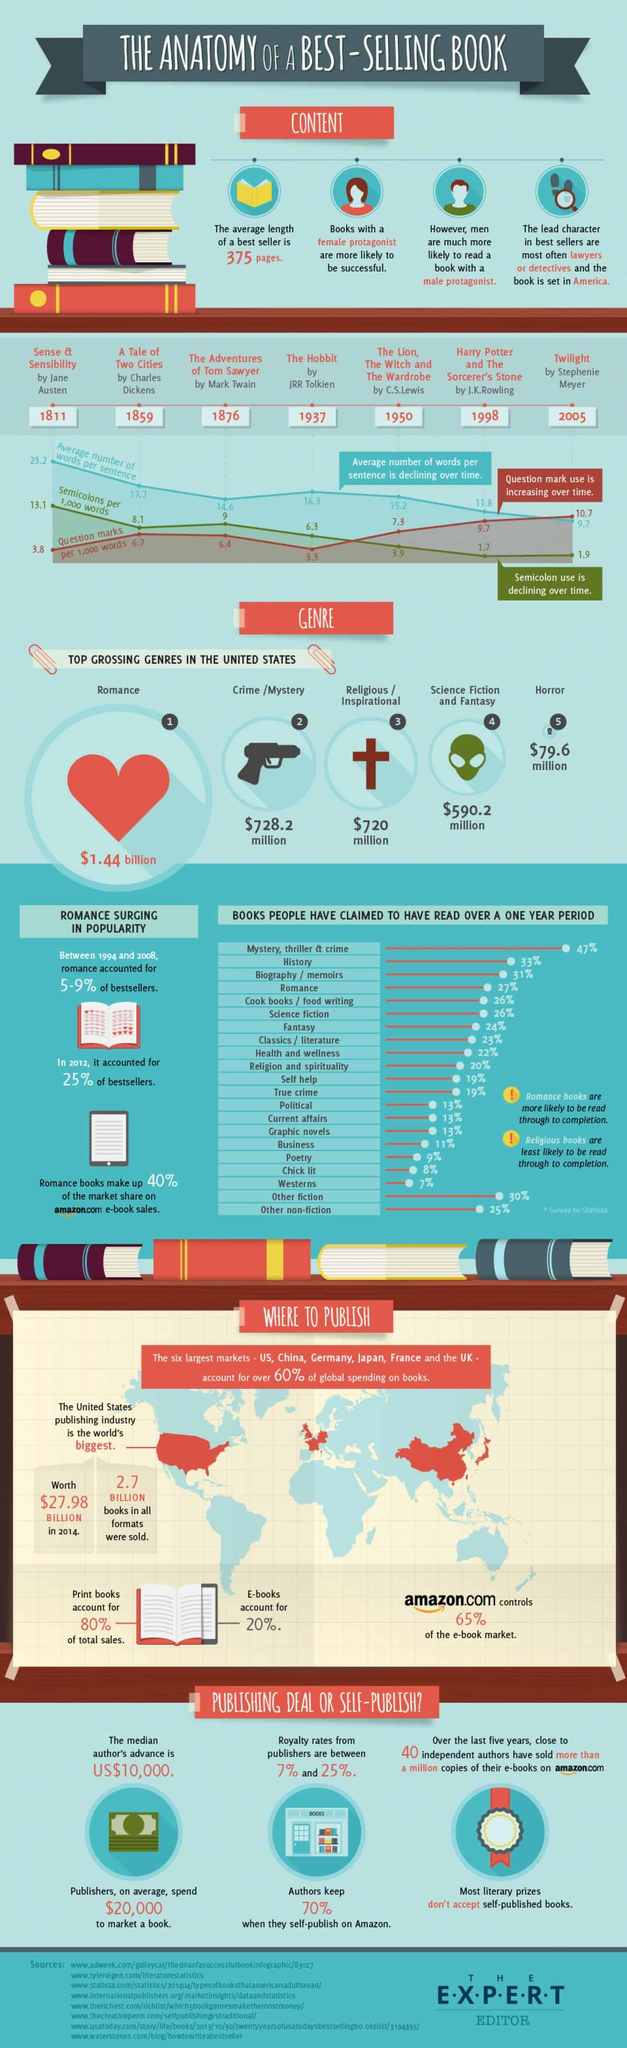When was the book "Twilight" published?
Answer the question with a short phrase. 2005 How many semicolons in 1000 words are there in the book "The Hobbit"? 6.3 Who is the author of the book "A Tale of Two Cities"? Charles Dickens When was the book "A Tale of Two Cities" published? 1859 Which book has the third-highest average of no of words in a sentence? The Hobbit How many Question marks are there in the book "The Lion, The Witch and The Wardrobe"? 7.3 Who wrote the book "Twilight"? Stephenie Meyer Which book has the highest no of Question marks? Twilight What is the average no of words in a sentence in the book "The Adventures of Tom Sawyer"? 14.6 Who wrote the book "The Hobbit"? JRR Tolkien 